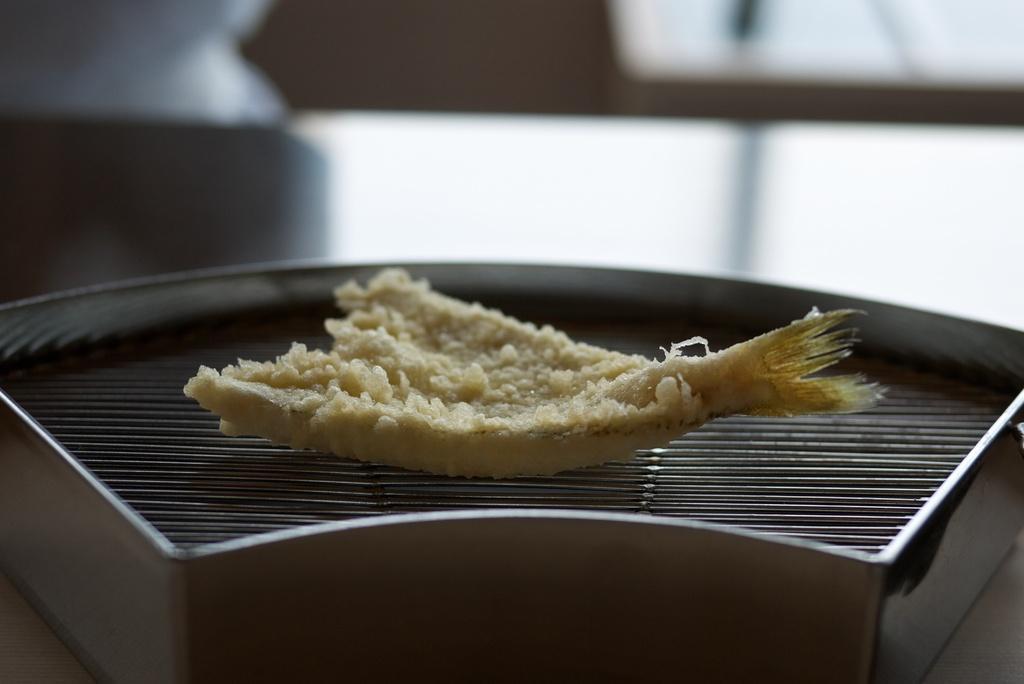Please provide a concise description of this image. In the center of the image we can see a food on the grill. At the top, the image is blurred. 